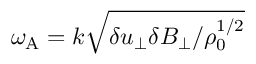Convert formula to latex. <formula><loc_0><loc_0><loc_500><loc_500>\omega _ { A } = k \sqrt { \delta u _ { \perp } \delta B _ { \perp } / \rho _ { 0 } ^ { 1 / 2 } }</formula> 